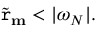<formula> <loc_0><loc_0><loc_500><loc_500>\widetilde { r } _ { m } < | \omega _ { N } | .</formula> 